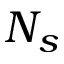Convert formula to latex. <formula><loc_0><loc_0><loc_500><loc_500>N _ { s }</formula> 